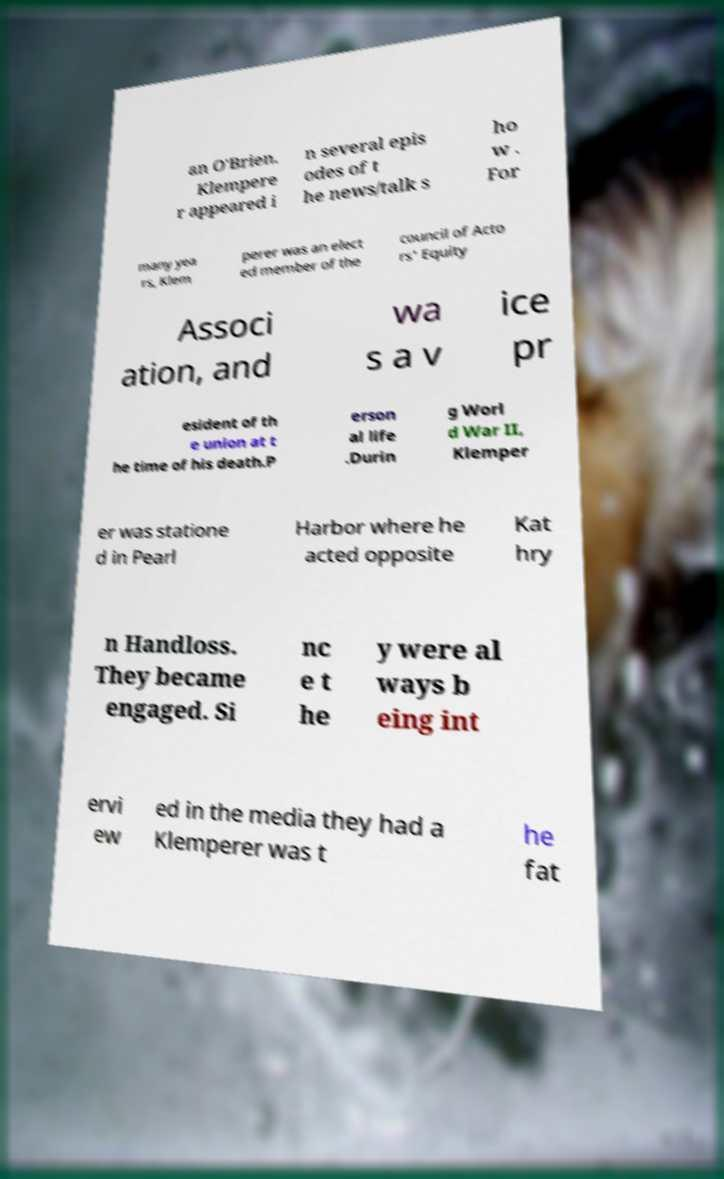Please identify and transcribe the text found in this image. an O'Brien. Klempere r appeared i n several epis odes of t he news/talk s ho w . For many yea rs, Klem perer was an elect ed member of the council of Acto rs' Equity Associ ation, and wa s a v ice pr esident of th e union at t he time of his death.P erson al life .Durin g Worl d War II, Klemper er was statione d in Pearl Harbor where he acted opposite Kat hry n Handloss. They became engaged. Si nc e t he y were al ways b eing int ervi ew ed in the media they had a Klemperer was t he fat 